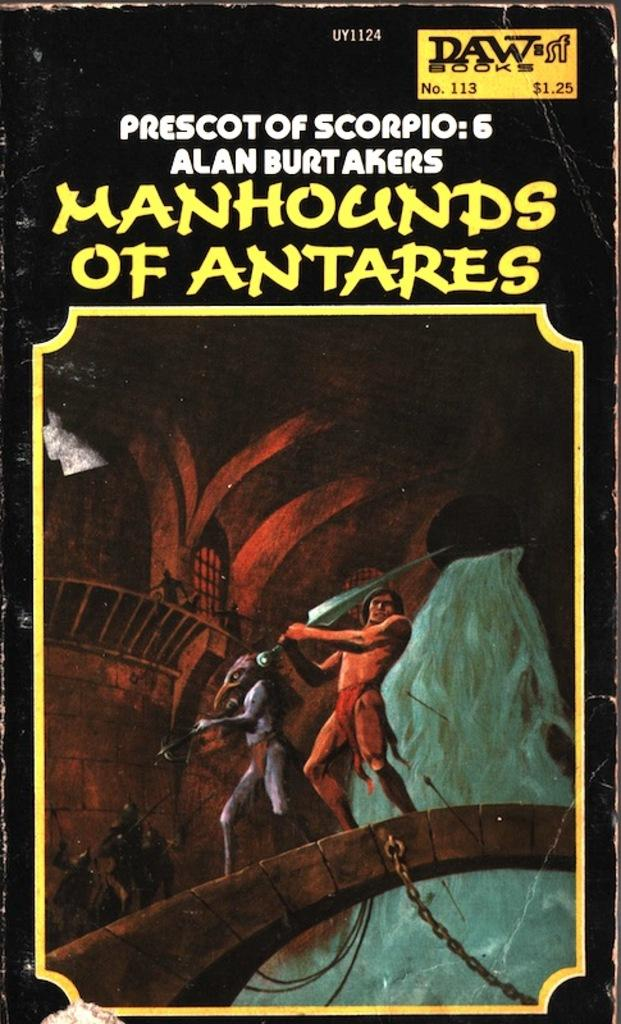<image>
Relay a brief, clear account of the picture shown. The old book pictured is called Manhounds of Antares. 